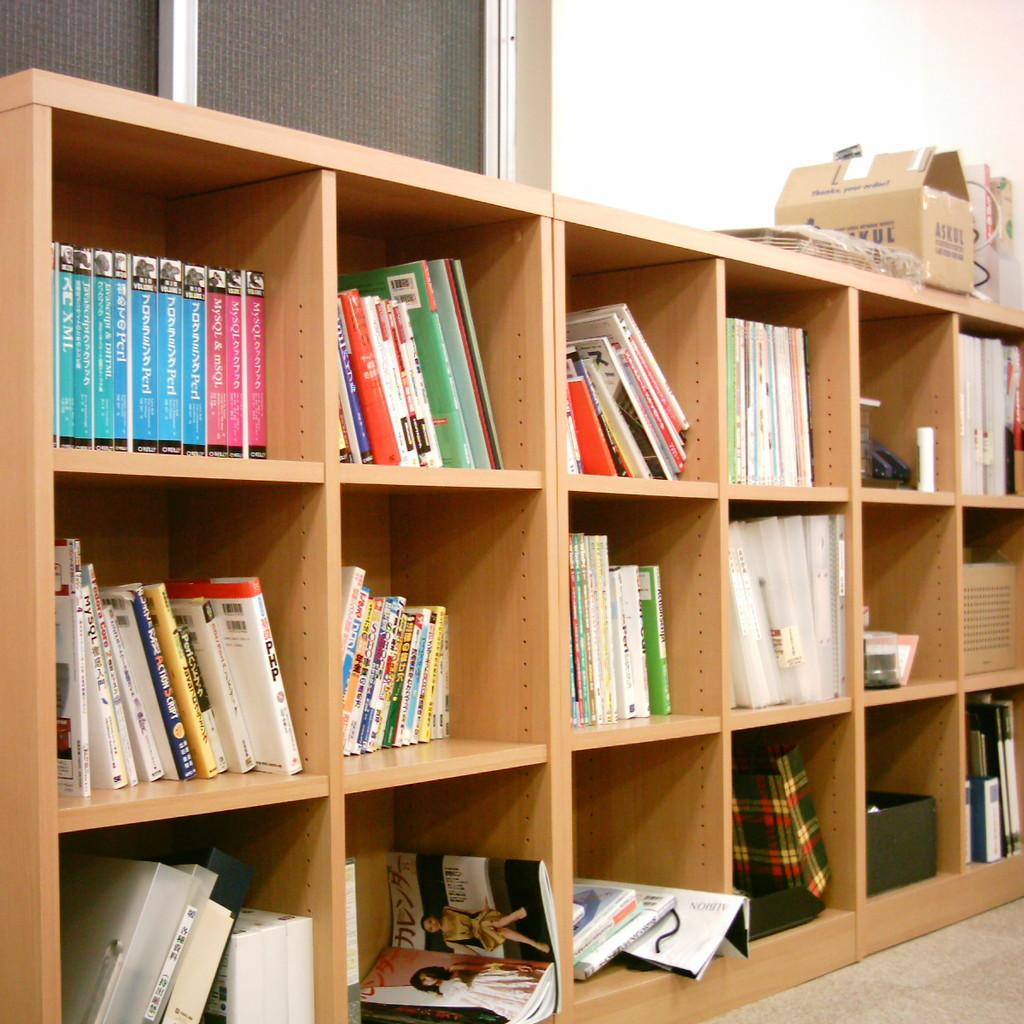What is the main object in the image? There is a rack in the image. What is on the rack? There are books on the rack. What else can be seen in the image besides the rack and books? There is a cardboard box in the image. What is visible in the background of the image? There is a wall in the background of the image. Is there any source of natural light in the image? Yes, there is a window in the image. What credit score does the person in the image have? There is no person present in the image, so it is impossible to determine their credit score. 